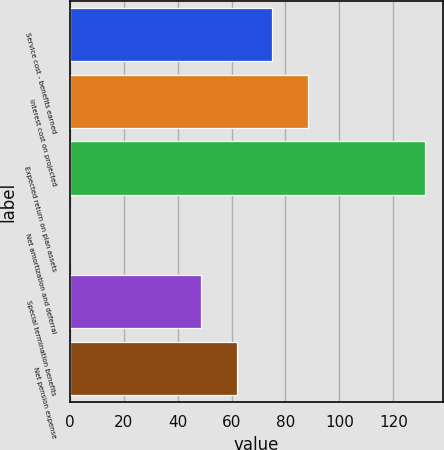<chart> <loc_0><loc_0><loc_500><loc_500><bar_chart><fcel>Service cost - benefits earned<fcel>Interest cost on projected<fcel>Expected return on plan assets<fcel>Net amortization and deferral<fcel>Special termination benefits<fcel>Net pension expense<nl><fcel>75.04<fcel>88.21<fcel>131.8<fcel>0.1<fcel>48.7<fcel>61.87<nl></chart> 